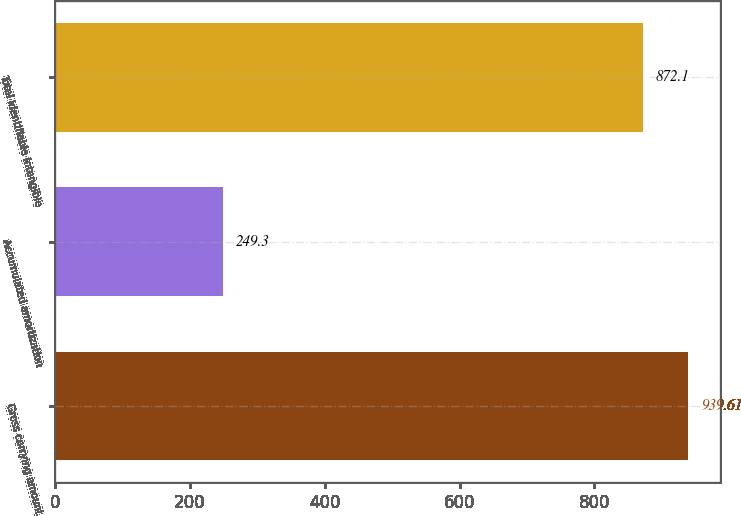Convert chart to OTSL. <chart><loc_0><loc_0><loc_500><loc_500><bar_chart><fcel>Gross carrying amount<fcel>Accumulated amortization<fcel>Total identifiable intangible<nl><fcel>939.61<fcel>249.3<fcel>872.1<nl></chart> 